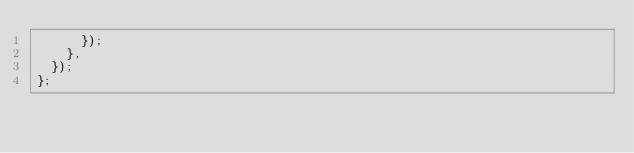Convert code to text. <code><loc_0><loc_0><loc_500><loc_500><_TypeScript_>      });
    },
  });
};
</code> 